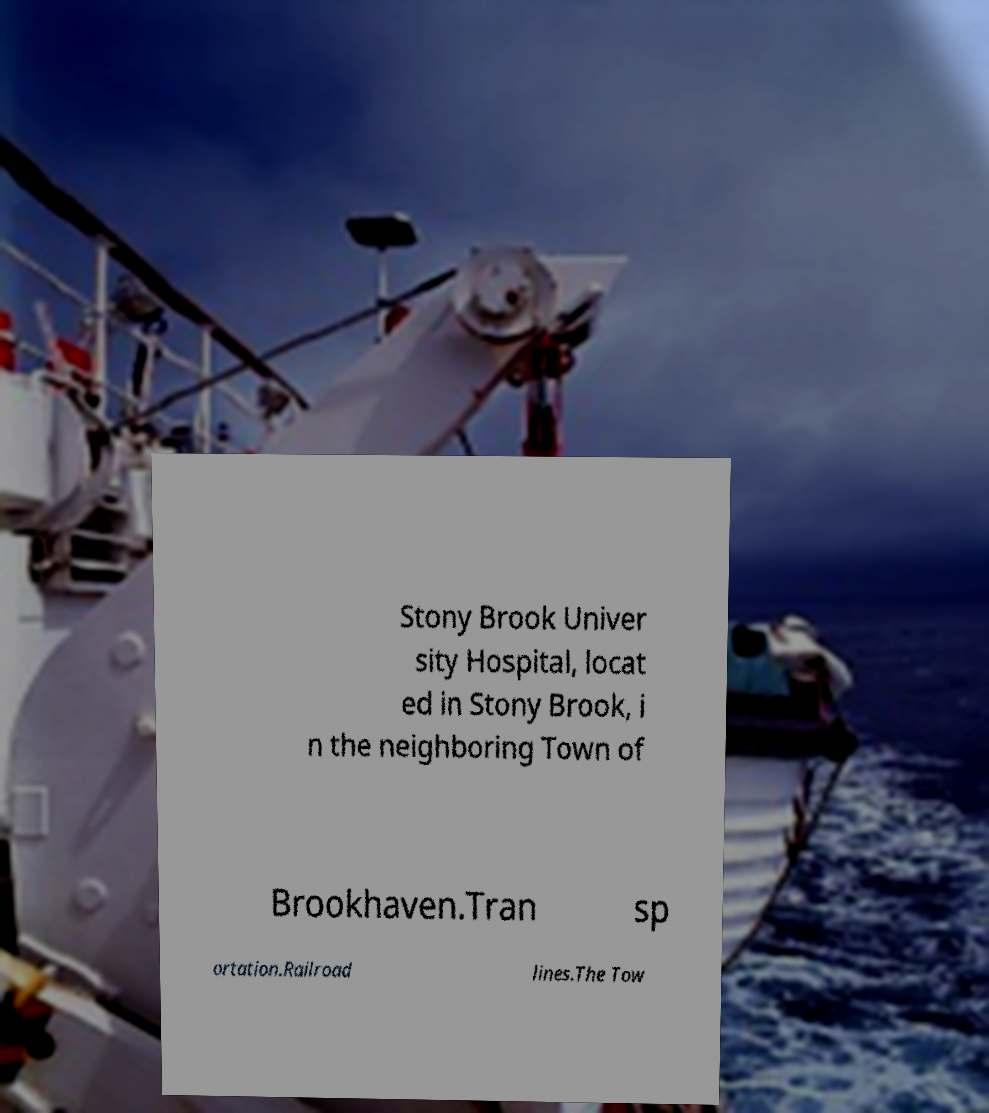Can you accurately transcribe the text from the provided image for me? Stony Brook Univer sity Hospital, locat ed in Stony Brook, i n the neighboring Town of Brookhaven.Tran sp ortation.Railroad lines.The Tow 